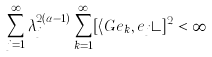Convert formula to latex. <formula><loc_0><loc_0><loc_500><loc_500>\sum _ { j = 1 } ^ { \infty } \lambda _ { j } ^ { 2 ( \alpha - 1 ) } \sum _ { k = 1 } ^ { \infty } [ \langle G e _ { k } , e _ { j } \rangle ] ^ { 2 } < \infty</formula> 